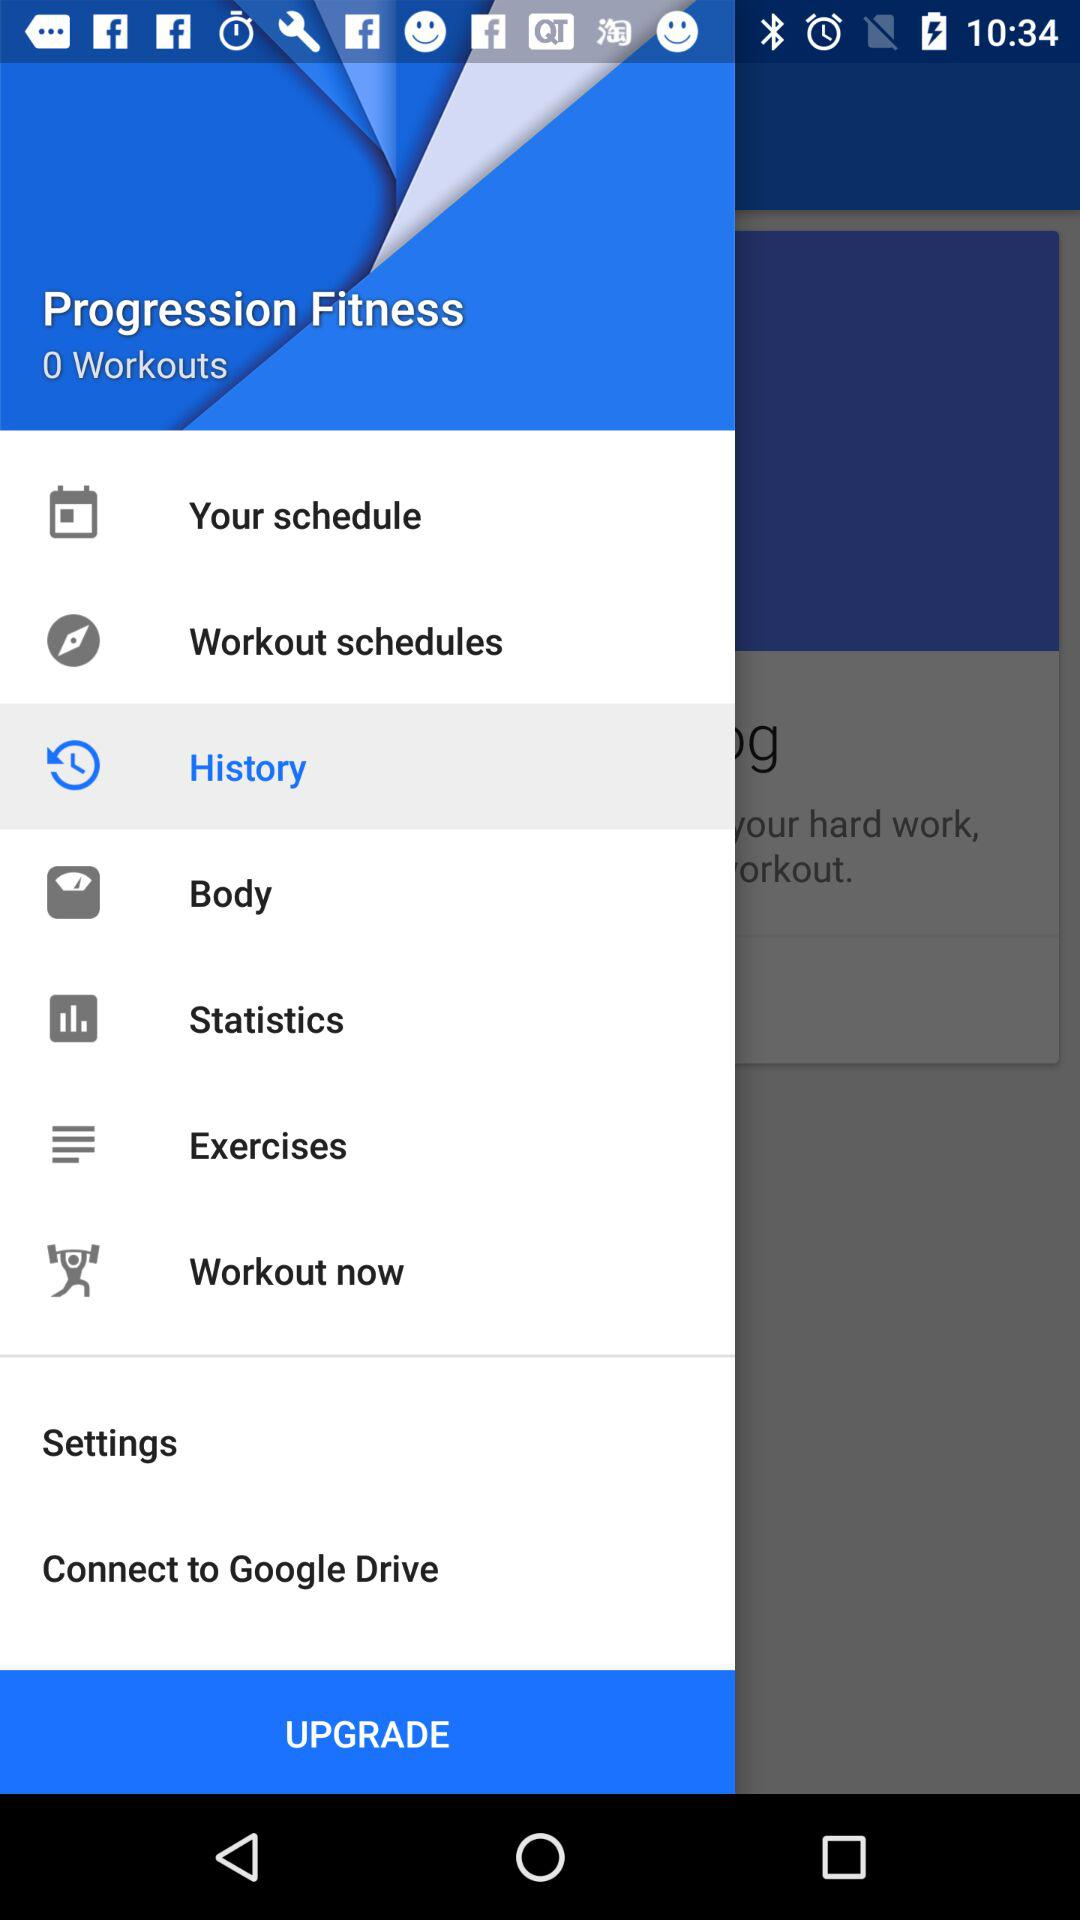What is the app name? The app name is "Progression Fitness". 